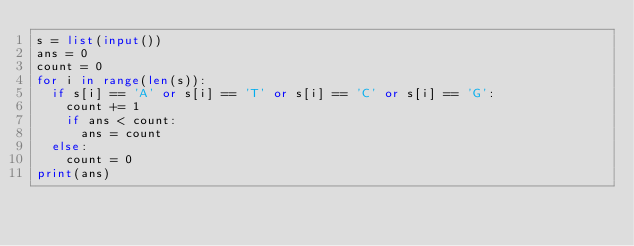<code> <loc_0><loc_0><loc_500><loc_500><_Python_>s = list(input())
ans = 0
count = 0
for i in range(len(s)):
  if s[i] == 'A' or s[i] == 'T' or s[i] == 'C' or s[i] == 'G':
    count += 1
    if ans < count:
      ans = count
  else:
    count = 0
print(ans)</code> 